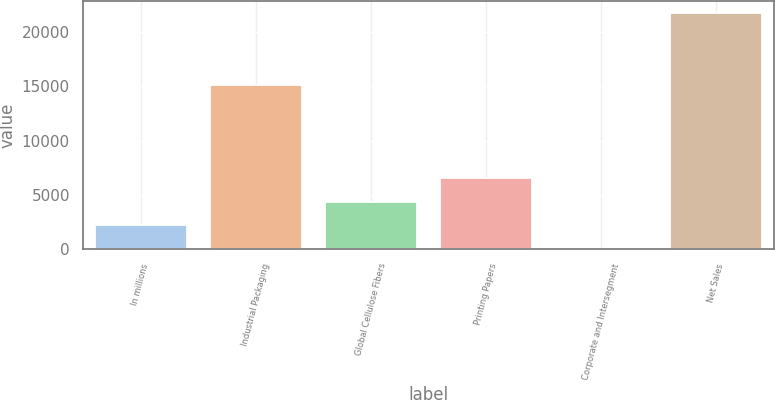<chart> <loc_0><loc_0><loc_500><loc_500><bar_chart><fcel>In millions<fcel>Industrial Packaging<fcel>Global Cellulose Fibers<fcel>Printing Papers<fcel>Corporate and Intersegment<fcel>Net Sales<nl><fcel>2212.1<fcel>15077<fcel>4382.2<fcel>6552.3<fcel>42<fcel>21743<nl></chart> 